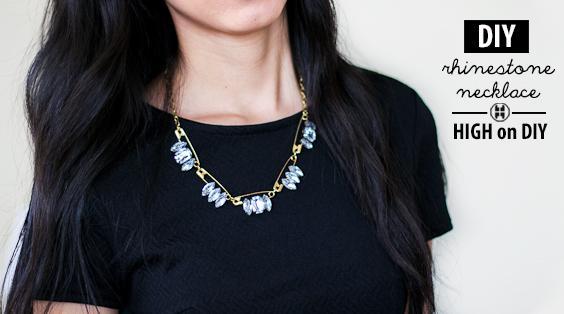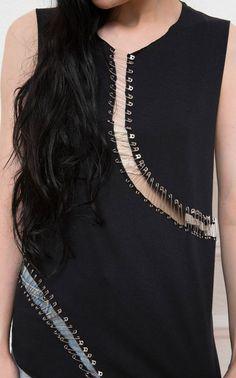The first image is the image on the left, the second image is the image on the right. Examine the images to the left and right. Is the description "An image shows a model wearing a sleeveless black top embellished with safety pins spanning tears in the fabric." accurate? Answer yes or no. Yes. 